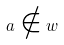<formula> <loc_0><loc_0><loc_500><loc_500>a \notin w</formula> 